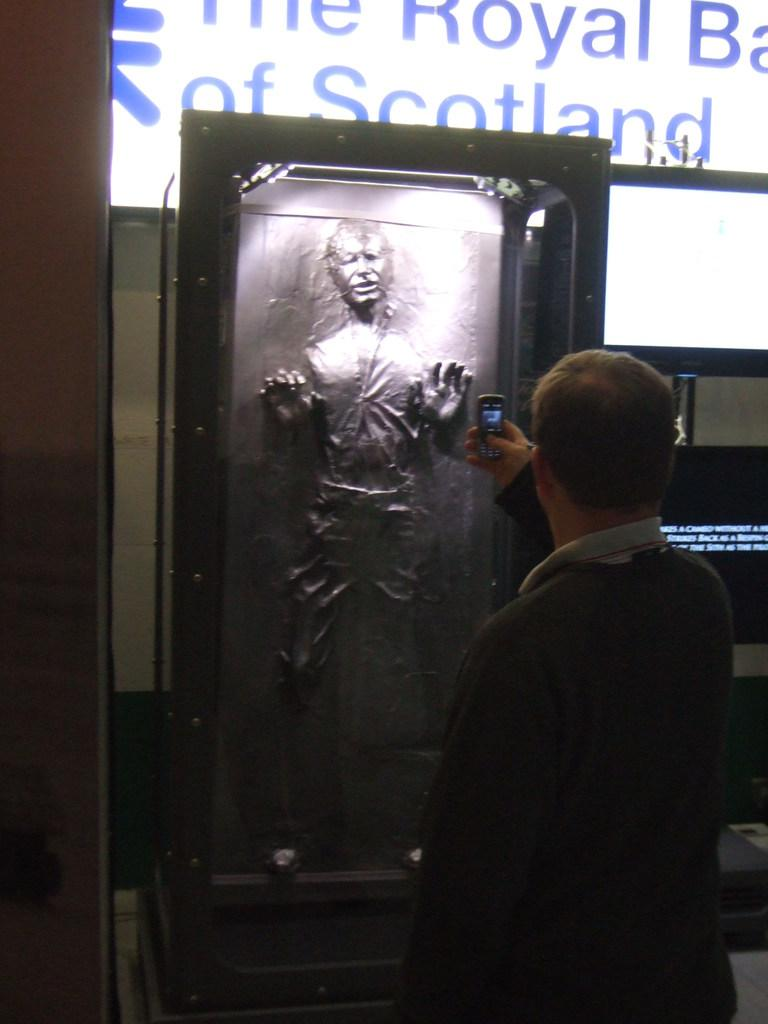Who is present in the image? There is a man in the image. What is the man holding in his hand? The man is holding a mobile in his hand. What can be seen in the background of the image? There is a statue in the background of the image. How is the statue positioned in relation to the man? The statue is inside a box in the background. What type of punishment is the man receiving in the image? There is no indication of punishment in the image; the man is simply holding a mobile in his hand. What unit of measurement is used to determine the size of the statue in the image? The provided facts do not mention any specific unit of measurement for the statue's size. 